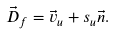Convert formula to latex. <formula><loc_0><loc_0><loc_500><loc_500>\vec { D } _ { f } = \vec { v } _ { u } + s _ { u } \vec { n } .</formula> 